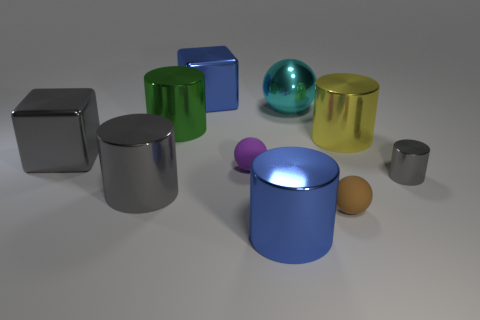Subtract all yellow cylinders. How many cylinders are left? 4 Subtract all tiny gray shiny cylinders. How many cylinders are left? 4 Subtract all purple cylinders. Subtract all yellow balls. How many cylinders are left? 5 Subtract all spheres. How many objects are left? 7 Subtract 0 brown cylinders. How many objects are left? 10 Subtract all tiny purple spheres. Subtract all big cyan shiny balls. How many objects are left? 8 Add 5 purple matte balls. How many purple matte balls are left? 6 Add 1 small red metallic cylinders. How many small red metallic cylinders exist? 1 